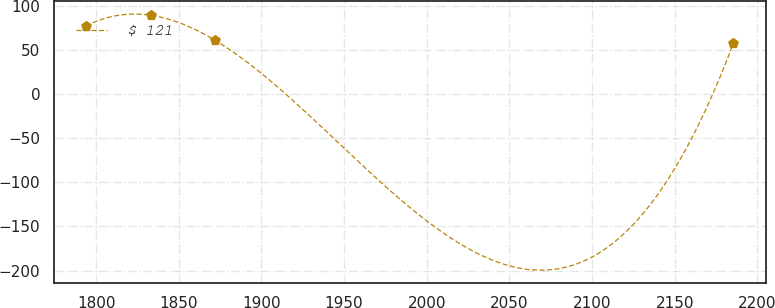Convert chart. <chart><loc_0><loc_0><loc_500><loc_500><line_chart><ecel><fcel>$ 121<nl><fcel>1793.85<fcel>77.03<nl><fcel>1833.01<fcel>89.1<nl><fcel>1872.17<fcel>60.52<nl><fcel>2185.48<fcel>57.34<nl></chart> 